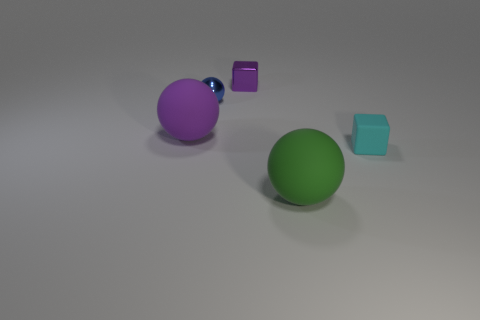Is there a rubber ball of the same color as the shiny cube?
Provide a succinct answer. Yes. Is the material of the tiny cube that is left of the small matte cube the same as the green sphere?
Keep it short and to the point. No. What number of large things are green metal spheres or cubes?
Give a very brief answer. 0. What is the size of the cyan thing?
Ensure brevity in your answer.  Small. There is a purple metallic object; does it have the same size as the rubber sphere that is right of the purple ball?
Your response must be concise. No. What number of blue things are tiny metallic objects or matte blocks?
Provide a short and direct response. 1. What number of brown rubber spheres are there?
Offer a very short reply. 0. How big is the thing on the right side of the green object?
Your response must be concise. Small. Do the blue object and the green sphere have the same size?
Make the answer very short. No. What number of things are either tiny cylinders or matte objects left of the blue ball?
Ensure brevity in your answer.  1. 